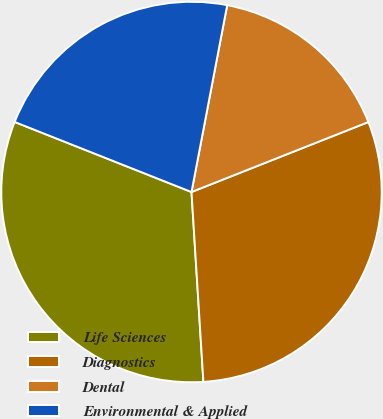<chart> <loc_0><loc_0><loc_500><loc_500><pie_chart><fcel>Life Sciences<fcel>Diagnostics<fcel>Dental<fcel>Environmental & Applied<nl><fcel>32.0%<fcel>30.0%<fcel>16.0%<fcel>22.0%<nl></chart> 